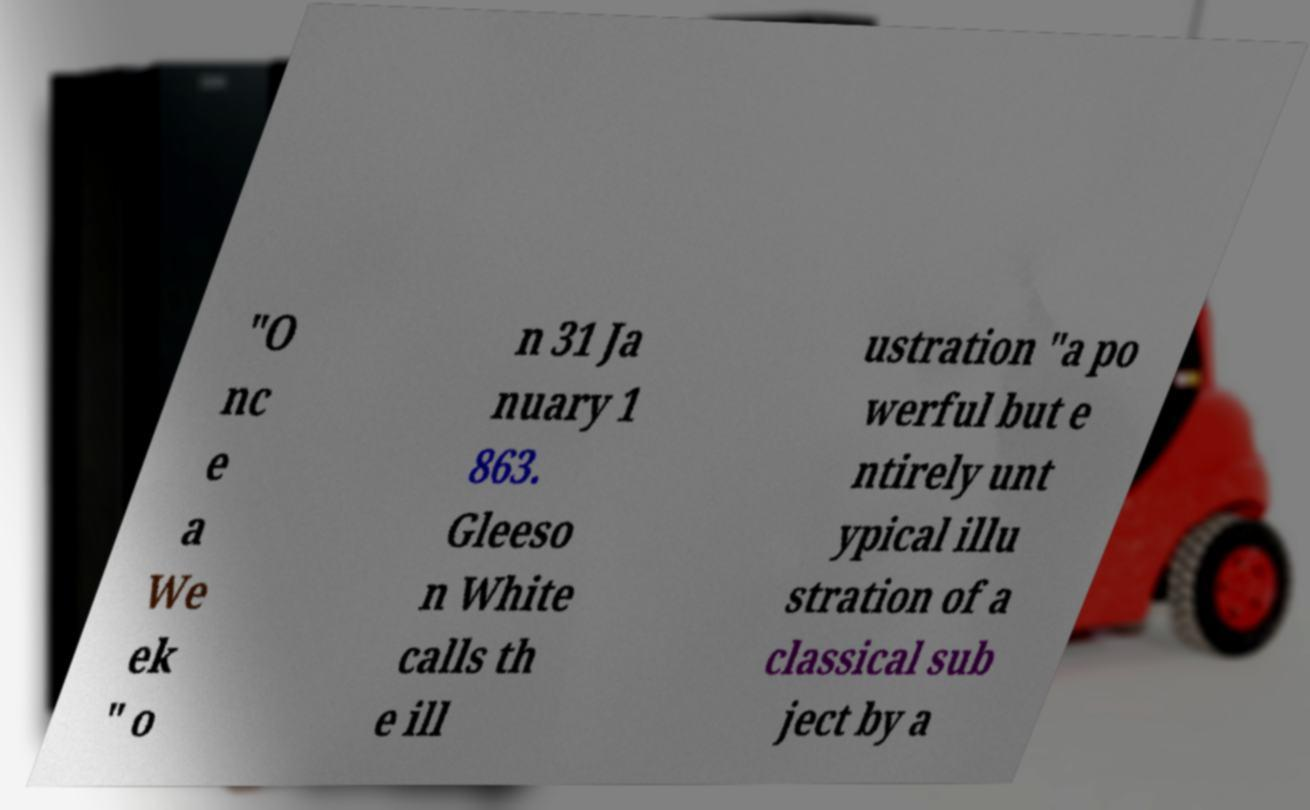Please identify and transcribe the text found in this image. "O nc e a We ek " o n 31 Ja nuary 1 863. Gleeso n White calls th e ill ustration "a po werful but e ntirely unt ypical illu stration of a classical sub ject by a 